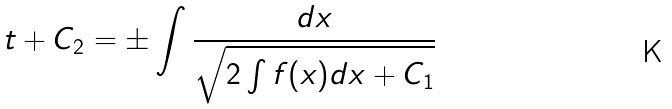<formula> <loc_0><loc_0><loc_500><loc_500>t + C _ { 2 } = \pm \int { \frac { d x } { \sqrt { 2 \int f ( x ) d x + C _ { 1 } } } }</formula> 